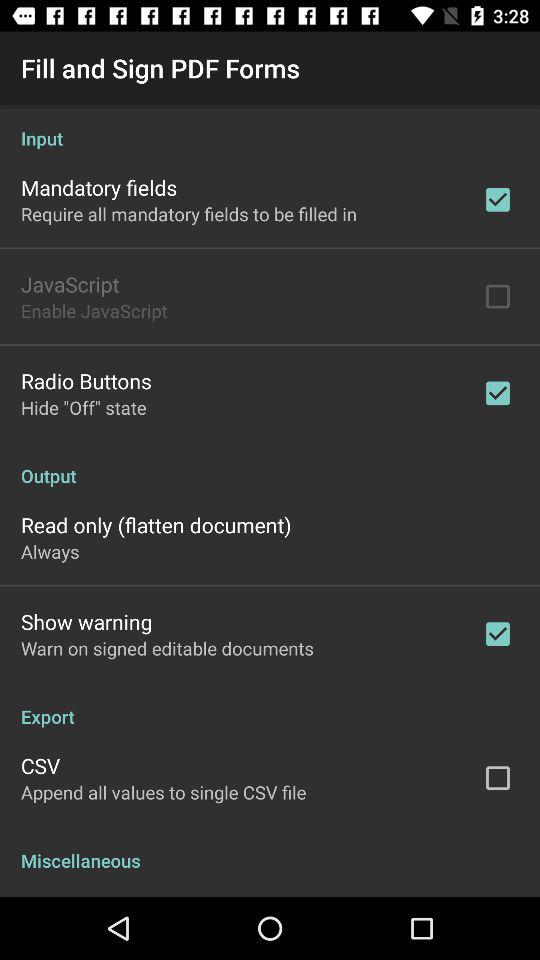What is the selected setting for "Read only (flatten document)"? The selected setting for "Read only (flatten document)" is "Always". 